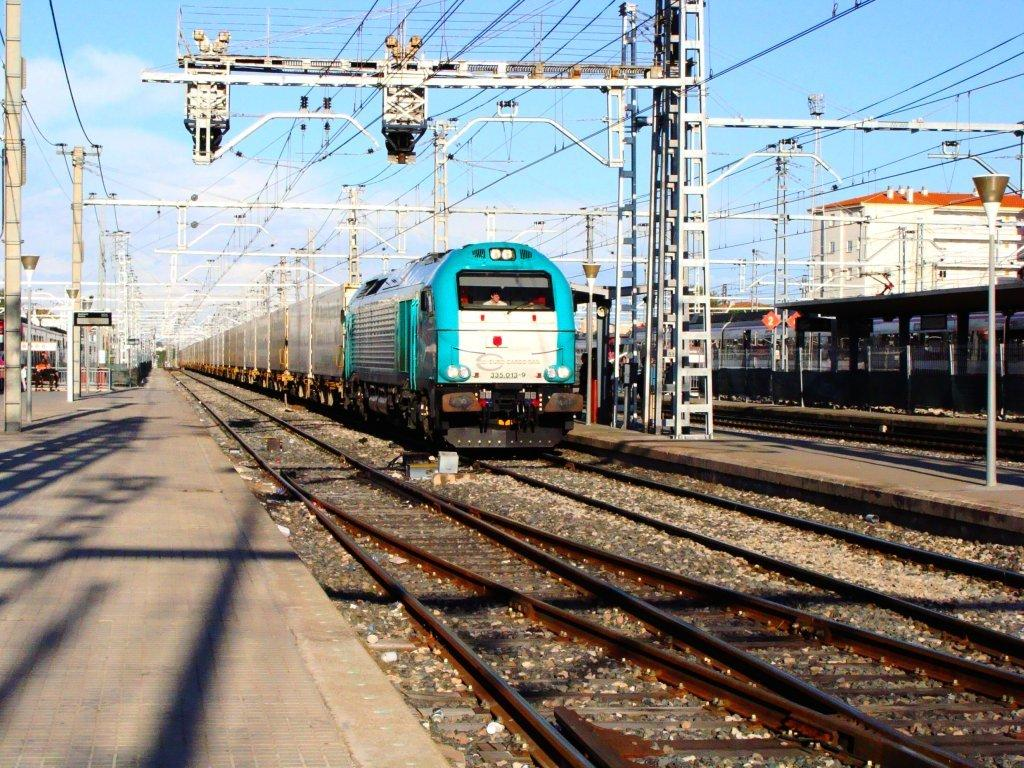What type of vehicles can be seen in the image? There are trains on railway tracks in the image. What is the location of the trains in the image? The trains are on railway tracks. What other structures are present in the image? There is a platform, poles, and wires in the image. What can be seen in the background of the image? The sky is visible in the background of the image, and clouds are present in the sky. What type of vest is the train conductor wearing in the image? There is no train conductor or vest present in the image. What is the color of the copper wire in the image? There is no copper wire present in the image. 